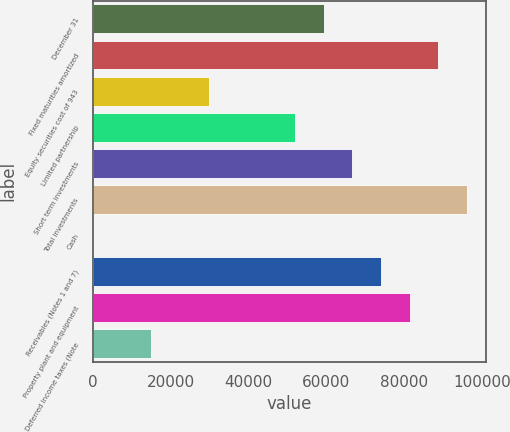<chart> <loc_0><loc_0><loc_500><loc_500><bar_chart><fcel>December 31<fcel>Fixed maturities amortized<fcel>Equity securities cost of 943<fcel>Limited partnership<fcel>Short term investments<fcel>Total investments<fcel>Cash<fcel>Receivables (Notes 1 and 7)<fcel>Property plant and equipment<fcel>Deferred income taxes (Note<nl><fcel>59294<fcel>88846<fcel>29742<fcel>51906<fcel>66682<fcel>96234<fcel>190<fcel>74070<fcel>81458<fcel>14966<nl></chart> 